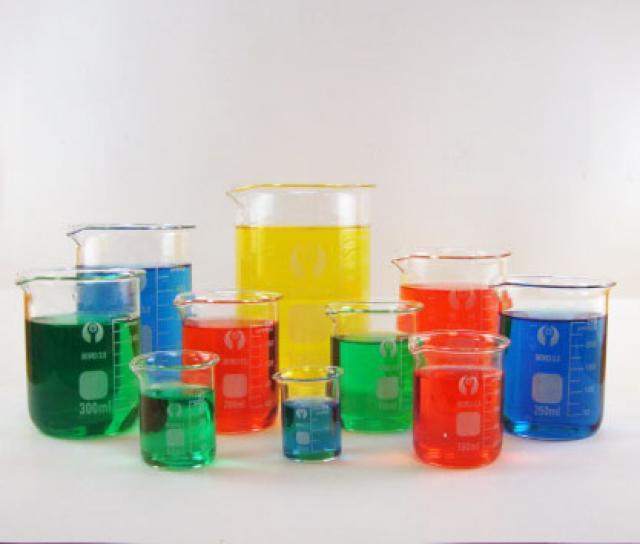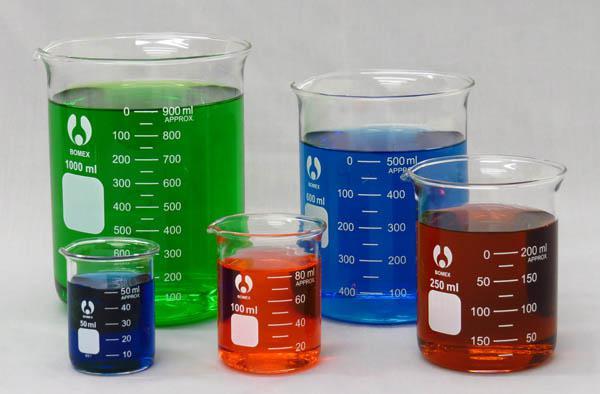The first image is the image on the left, the second image is the image on the right. For the images displayed, is the sentence "There are unfilled beakers." factually correct? Answer yes or no. No. The first image is the image on the left, the second image is the image on the right. For the images displayed, is the sentence "In at least one image there are five beckers with only two full of blue liquid." factually correct? Answer yes or no. Yes. 